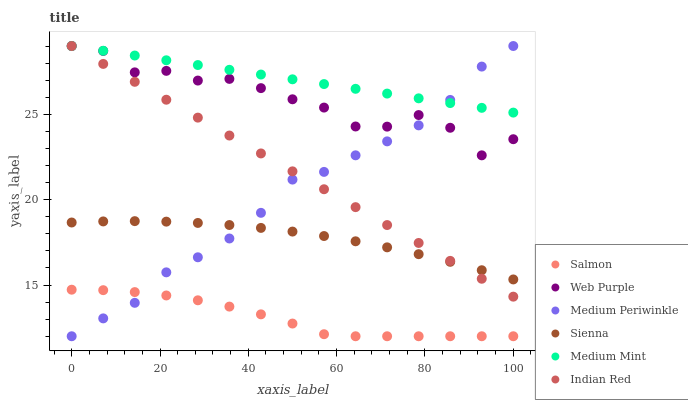Does Salmon have the minimum area under the curve?
Answer yes or no. Yes. Does Medium Mint have the maximum area under the curve?
Answer yes or no. Yes. Does Medium Periwinkle have the minimum area under the curve?
Answer yes or no. No. Does Medium Periwinkle have the maximum area under the curve?
Answer yes or no. No. Is Medium Mint the smoothest?
Answer yes or no. Yes. Is Web Purple the roughest?
Answer yes or no. Yes. Is Salmon the smoothest?
Answer yes or no. No. Is Salmon the roughest?
Answer yes or no. No. Does Salmon have the lowest value?
Answer yes or no. Yes. Does Sienna have the lowest value?
Answer yes or no. No. Does Indian Red have the highest value?
Answer yes or no. Yes. Does Salmon have the highest value?
Answer yes or no. No. Is Salmon less than Indian Red?
Answer yes or no. Yes. Is Medium Mint greater than Salmon?
Answer yes or no. Yes. Does Medium Mint intersect Medium Periwinkle?
Answer yes or no. Yes. Is Medium Mint less than Medium Periwinkle?
Answer yes or no. No. Is Medium Mint greater than Medium Periwinkle?
Answer yes or no. No. Does Salmon intersect Indian Red?
Answer yes or no. No. 